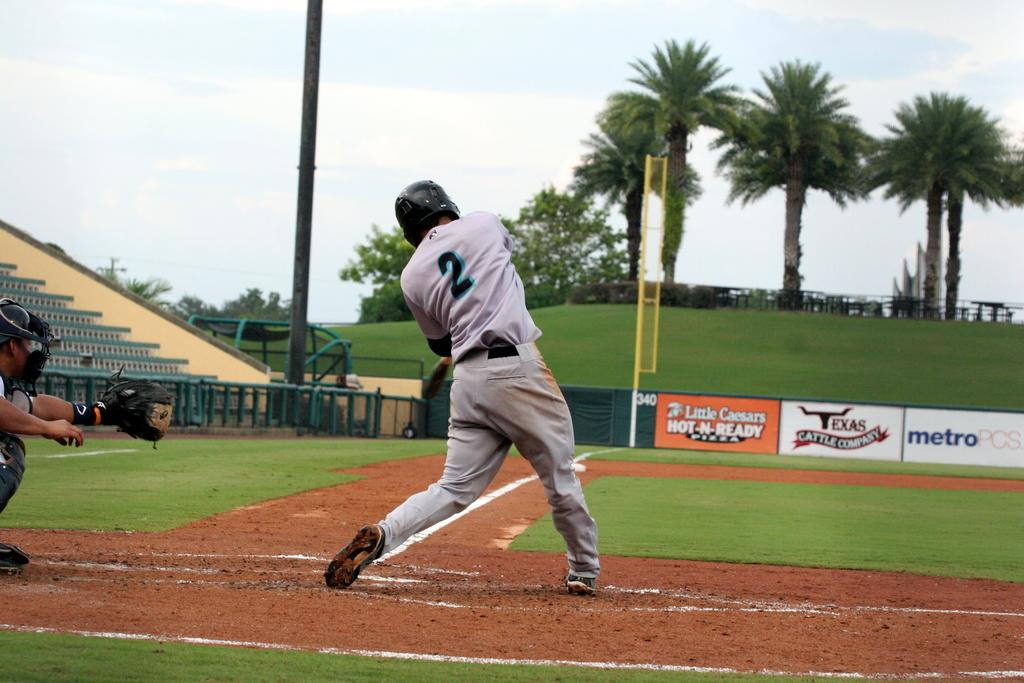<image>
Offer a succinct explanation of the picture presented. A baseball player wearing number 2 swinging a bat. 